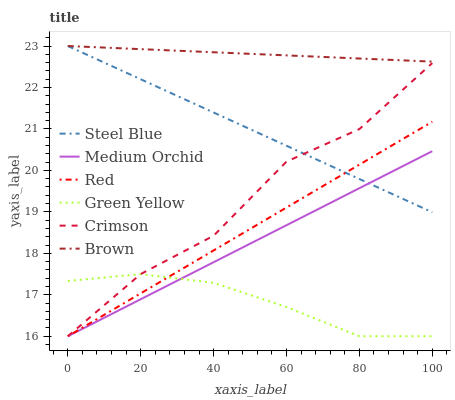Does Green Yellow have the minimum area under the curve?
Answer yes or no. Yes. Does Brown have the maximum area under the curve?
Answer yes or no. Yes. Does Medium Orchid have the minimum area under the curve?
Answer yes or no. No. Does Medium Orchid have the maximum area under the curve?
Answer yes or no. No. Is Red the smoothest?
Answer yes or no. Yes. Is Crimson the roughest?
Answer yes or no. Yes. Is Medium Orchid the smoothest?
Answer yes or no. No. Is Medium Orchid the roughest?
Answer yes or no. No. Does Medium Orchid have the lowest value?
Answer yes or no. Yes. Does Steel Blue have the lowest value?
Answer yes or no. No. Does Steel Blue have the highest value?
Answer yes or no. Yes. Does Medium Orchid have the highest value?
Answer yes or no. No. Is Green Yellow less than Steel Blue?
Answer yes or no. Yes. Is Brown greater than Red?
Answer yes or no. Yes. Does Steel Blue intersect Crimson?
Answer yes or no. Yes. Is Steel Blue less than Crimson?
Answer yes or no. No. Is Steel Blue greater than Crimson?
Answer yes or no. No. Does Green Yellow intersect Steel Blue?
Answer yes or no. No. 